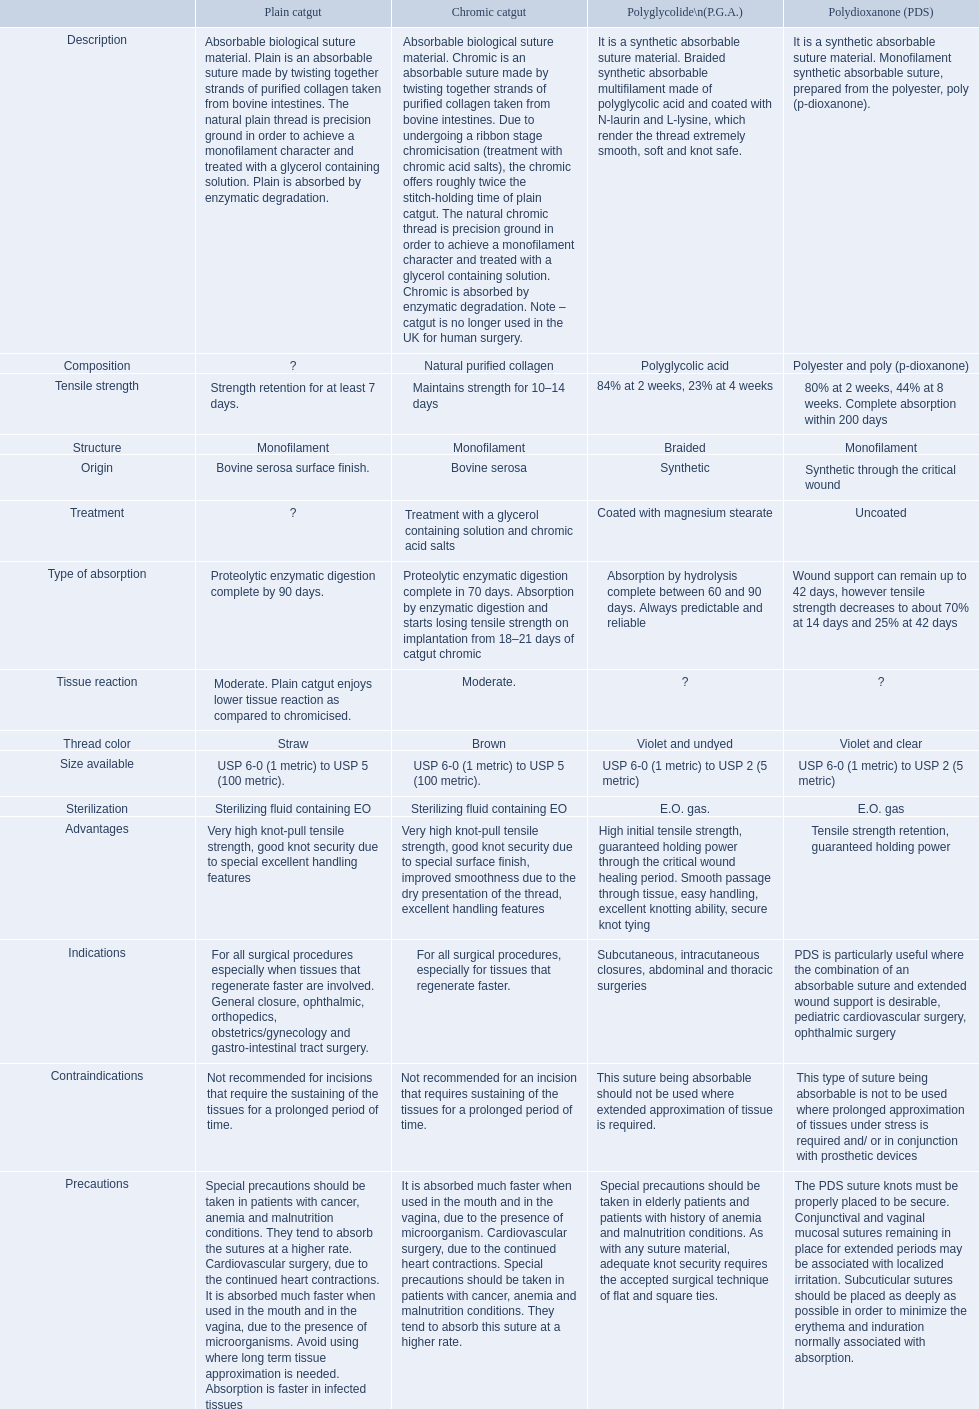For how long does chronic catgut maintain its strength? Maintains strength for 10–14 days. What is the definition of plain catgut? Absorbable biological suture material. Plain is an absorbable suture made by twisting together strands of purified collagen taken from bovine intestines. The natural plain thread is precision ground in order to achieve a monofilament character and treated with a glycerol containing solution. Plain is absorbed by enzymatic degradation. Over how many days does catgut preserve its strength? Strength retention for at least 7 days. 